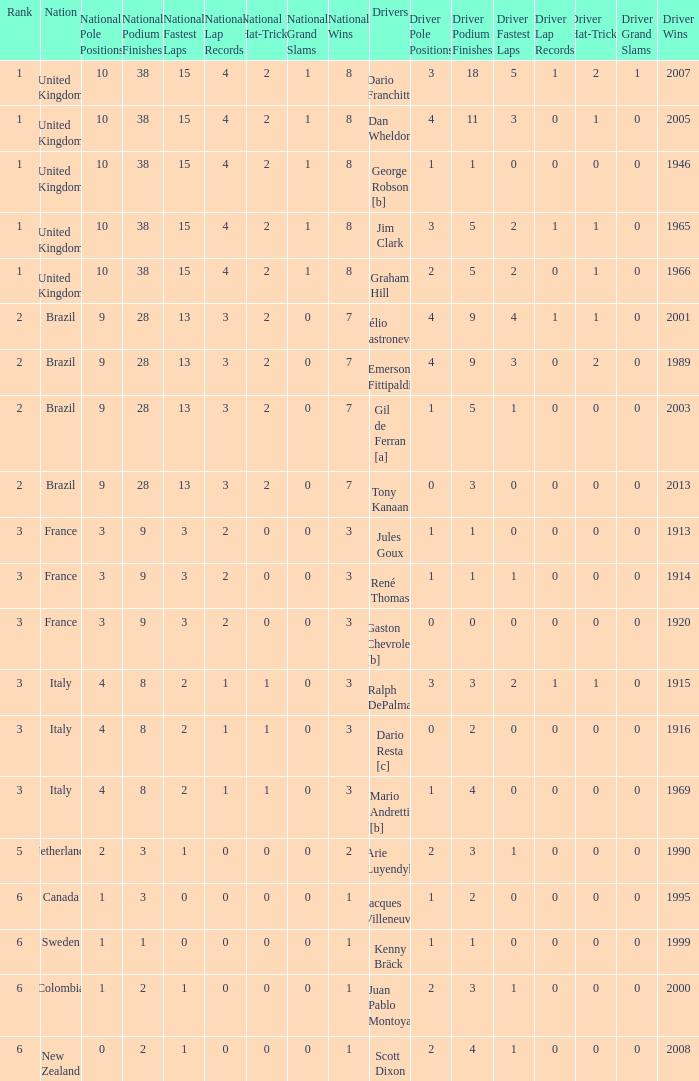Parse the full table. {'header': ['Rank', 'Nation', 'National Pole Positions', 'National Podium Finishes', 'National Fastest Laps', 'National Lap Records', 'National Hat-Tricks', 'National Grand Slams', 'National Wins', 'Drivers', 'Driver Pole Positions', 'Driver Podium Finishes', 'Driver Fastest Laps', 'Driver Lap Records', 'Driver Hat-Tricks', 'Driver Grand Slams', 'Driver Wins'], 'rows': [['1', 'United Kingdom', '10', '38', '15', '4', '2', '1', '8', 'Dario Franchitti', '3', '18', '5', '1', '2', '1', '2007'], ['1', 'United Kingdom', '10', '38', '15', '4', '2', '1', '8', 'Dan Wheldon', '4', '11', '3', '0', '1', '0', '2005'], ['1', 'United Kingdom', '10', '38', '15', '4', '2', '1', '8', 'George Robson [b]', '1', '1', '0', '0', '0', '0', '1946'], ['1', 'United Kingdom', '10', '38', '15', '4', '2', '1', '8', 'Jim Clark', '3', '5', '2', '1', '1', '0', '1965'], ['1', 'United Kingdom', '10', '38', '15', '4', '2', '1', '8', 'Graham Hill', '2', '5', '2', '0', '1', '0', '1966'], ['2', 'Brazil', '9', '28', '13', '3', '2', '0', '7', 'Hélio Castroneves', '4', '9', '4', '1', '1', '0', '2001'], ['2', 'Brazil', '9', '28', '13', '3', '2', '0', '7', 'Emerson Fittipaldi', '4', '9', '3', '0', '2', '0', '1989'], ['2', 'Brazil', '9', '28', '13', '3', '2', '0', '7', 'Gil de Ferran [a]', '1', '5', '1', '0', '0', '0', '2003'], ['2', 'Brazil', '9', '28', '13', '3', '2', '0', '7', 'Tony Kanaan', '0', '3', '0', '0', '0', '0', '2013'], ['3', 'France', '3', '9', '3', '2', '0', '0', '3', 'Jules Goux', '1', '1', '0', '0', '0', '0', '1913'], ['3', 'France', '3', '9', '3', '2', '0', '0', '3', 'René Thomas', '1', '1', '1', '0', '0', '0', '1914'], ['3', 'France', '3', '9', '3', '2', '0', '0', '3', 'Gaston Chevrolet [b]', '0', '0', '0', '0', '0', '0', '1920'], ['3', 'Italy', '4', '8', '2', '1', '1', '0', '3', 'Ralph DePalma', '3', '3', '2', '1', '1', '0', '1915'], ['3', 'Italy', '4', '8', '2', '1', '1', '0', '3', 'Dario Resta [c]', '0', '2', '0', '0', '0', '0', '1916'], ['3', 'Italy', '4', '8', '2', '1', '1', '0', '3', 'Mario Andretti [b]', '1', '4', '0', '0', '0', '0', '1969'], ['5', 'Netherlands', '2', '3', '1', '0', '0', '0', '2', 'Arie Luyendyk', '2', '3', '1', '0', '0', '0', '1990'], ['6', 'Canada', '1', '3', '0', '0', '0', '0', '1', 'Jacques Villeneuve', '1', '2', '0', '0', '0', '0', '1995'], ['6', 'Sweden', '1', '1', '0', '0', '0', '0', '1', 'Kenny Bräck', '1', '1', '0', '0', '0', '0', '1999'], ['6', 'Colombia', '1', '2', '1', '0', '0', '0', '1', 'Juan Pablo Montoya', '2', '3', '1', '0', '0', '0', '2000'], ['6', 'New Zealand', '0', '2', '1', '0', '0', '0', '1', 'Scott Dixon', '2', '4', '1', '0', '0', '0', '2008']]} What is the average number of wins of drivers from Sweden? 1999.0. 